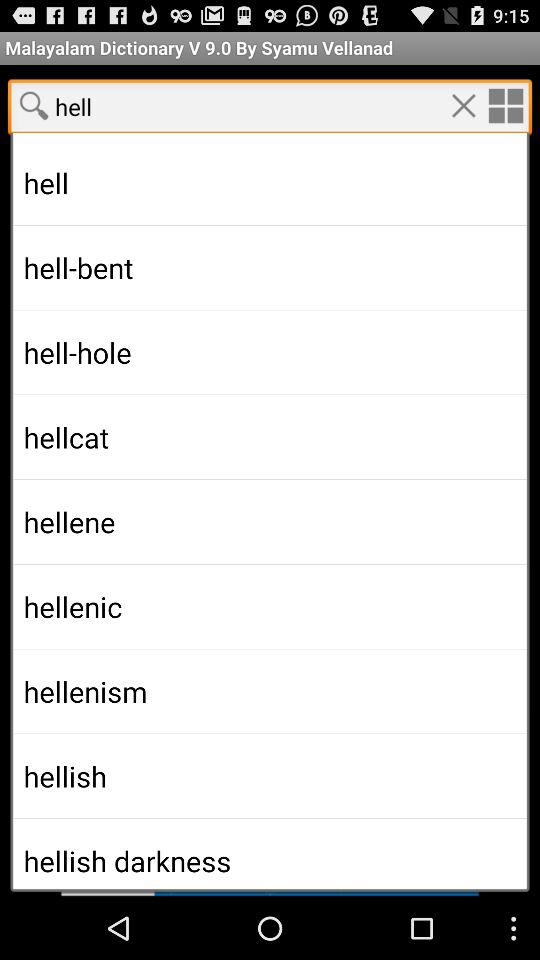Who is the writer of the "Malayalam Dictionary"? The writer of the "Malayalam Dictionary" is Syamu Vellanad. 